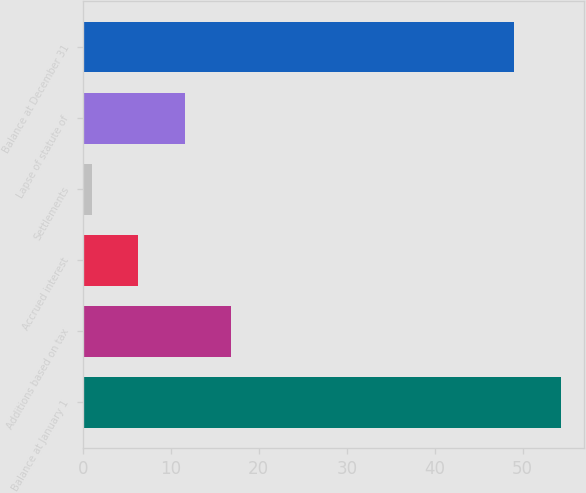Convert chart to OTSL. <chart><loc_0><loc_0><loc_500><loc_500><bar_chart><fcel>Balance at January 1<fcel>Additions based on tax<fcel>Accrued interest<fcel>Settlements<fcel>Lapse of statute of<fcel>Balance at December 31<nl><fcel>54.3<fcel>16.9<fcel>6.3<fcel>1<fcel>11.6<fcel>49<nl></chart> 